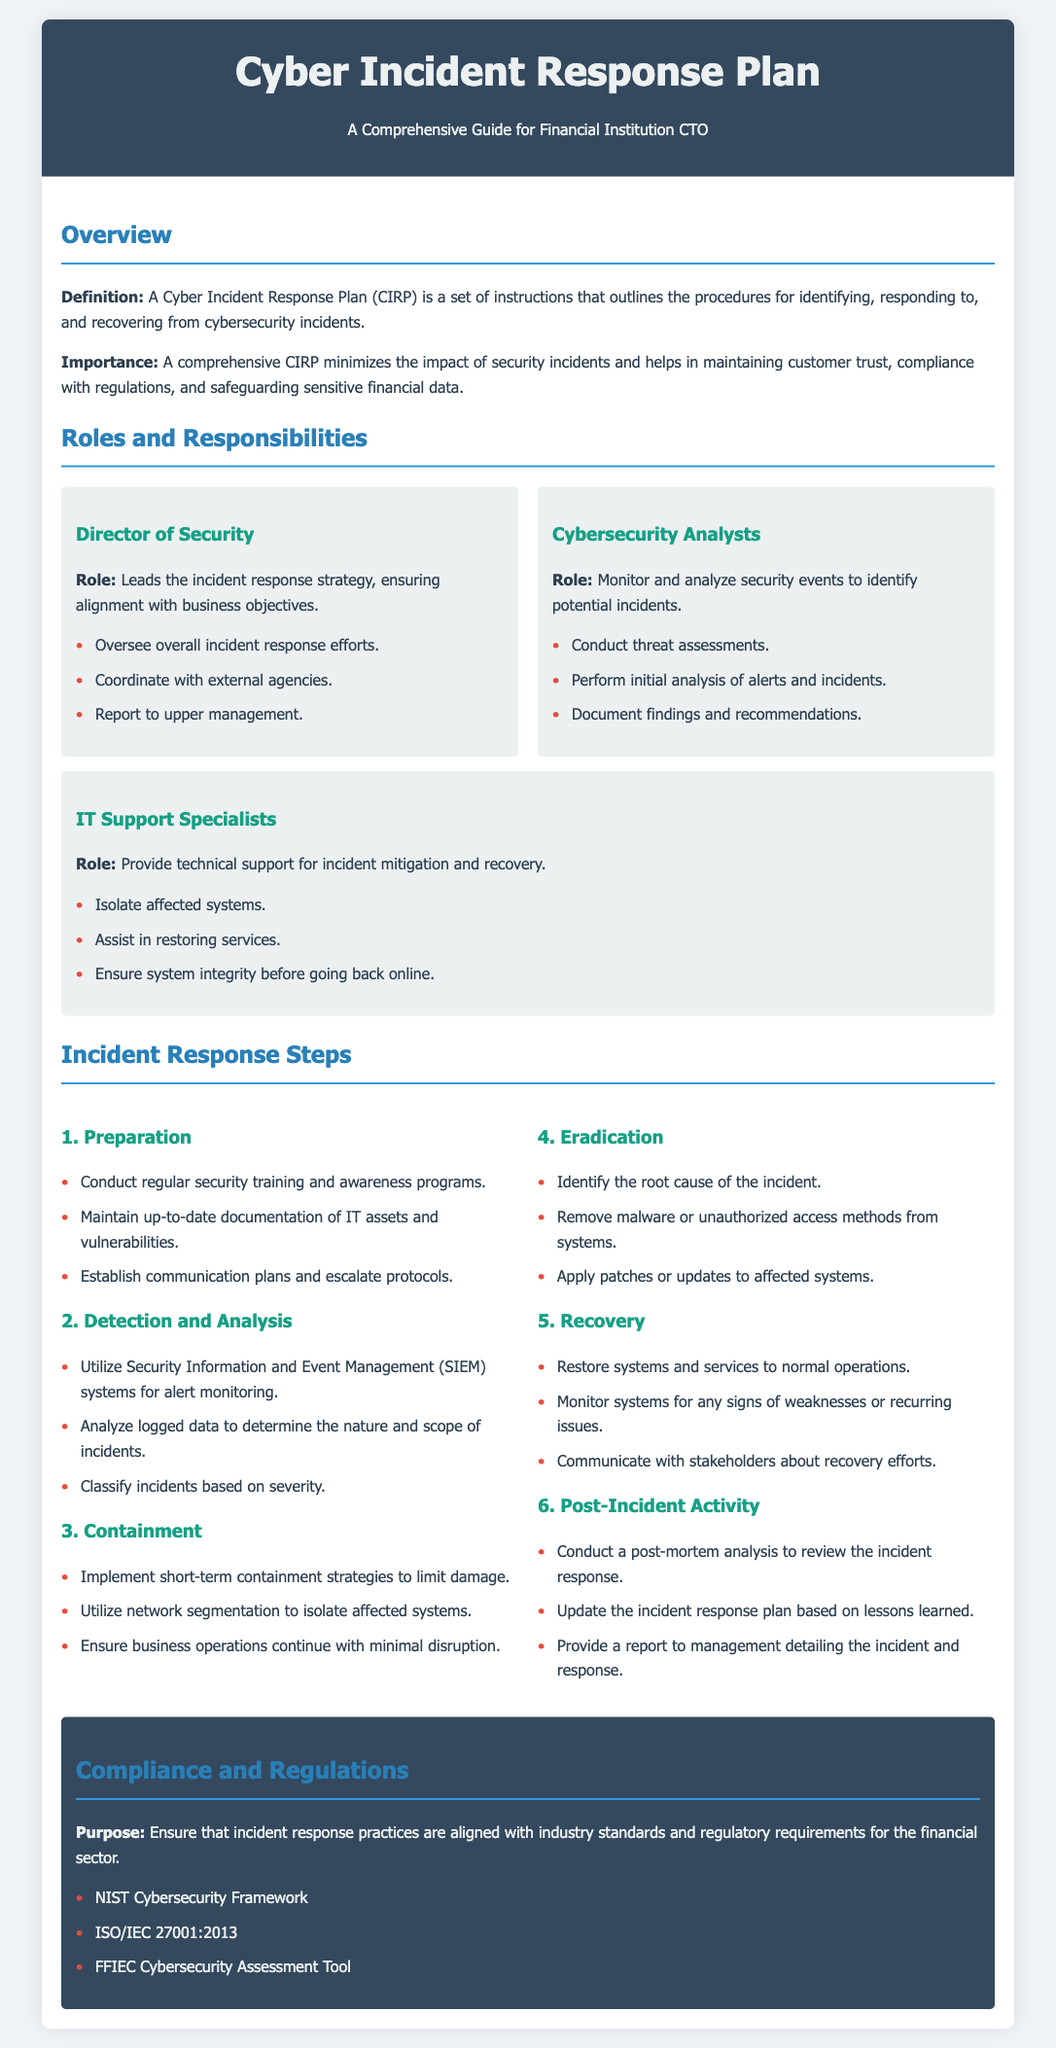What is the purpose of a Cyber Incident Response Plan? The purpose is outlined in the overview section, which highlights the procedures for identifying, responding to, and recovering from cybersecurity incidents.
Answer: A set of instructions for identifying, responding to, and recovering from cybersecurity incidents Who leads the incident response strategy? This role is specified under the Roles and Responsibilities section, where it mentions the Director of Security.
Answer: Director of Security What is a key task of Cybersecurity Analysts? The document lists key responsibilities for Cybersecurity Analysts, one of which is conducting threat assessments.
Answer: Conduct threat assessments What is the first step in the Incident Response Steps? The first step is detailed in the Incident Response Steps section, specifically under the Preparation heading.
Answer: Preparation Which framework is mentioned under Compliance and Regulations? The document lists compliance frameworks that align with incident response practices, one of which is NIST Cybersecurity Framework.
Answer: NIST Cybersecurity Framework What is one responsibility of IT Support Specialists? The responsibilities of IT Support Specialists are listed, including ensuring system integrity before going back online.
Answer: Ensure system integrity before going back online What should be done during post-incident activity? The document outlines several activities, one being to provide a report to management detailing the incident and response.
Answer: Provide a report to management detailing the incident and response 